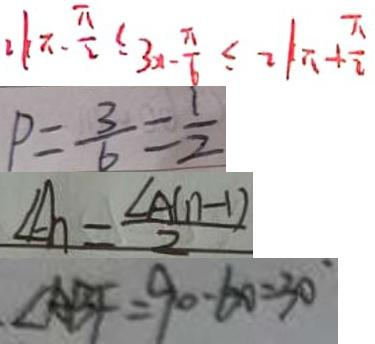<formula> <loc_0><loc_0><loc_500><loc_500>2 k \pi - \frac { \pi } { 2 } \leq 3 x - \frac { \pi } { 6 } \leq 2 k \pi + \frac { \pi } { 2 } 
 P = \frac { 3 } { 6 } = \frac { 1 } { 2 } 
 \angle A _ { n } = \frac { \angle A ( n - 1 ) } { 2 } 
 \angle A B F = 9 0 - 6 0 = 3 0 ^ { \circ }</formula> 